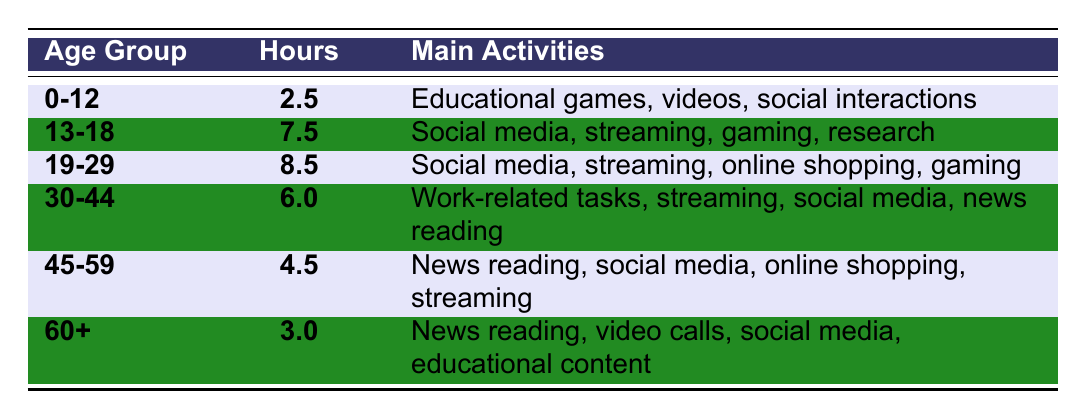What is the average daily internet usage for the age group 19-29? The value for the age group 19-29 is clearly listed in the table as 8.5 hours.
Answer: 8.5 hours Which age group has the highest average daily internet usage? By comparing the values in the table, 19-29 has the highest usage at 8.5 hours.
Answer: 19-29 How many hours do people aged 30-44 spend online daily? The table shows that the age group 30-44 spends 6.0 hours online.
Answer: 6.0 hours What activities do people aged 45-59 engage in online? The table lists the main activities for this age group as news reading, social media, online shopping, and streaming.
Answer: News reading, social media, online shopping, streaming Is the average daily internet usage for the age group 60+ higher than that of the age group 0-12? Comparing the two values, 3.0 hours (60+) is higher than 2.5 hours (0-12), which makes the statement true.
Answer: Yes What is the difference between the daily internet usage of 13-18 and 45-59 age groups? Subtracting the values gives us 7.5 hours (13-18) - 4.5 hours (45-59) = 3.0 hours difference.
Answer: 3.0 hours Which age group has an average usage of less than 5 hours? The age groups with usage less than 5 hours according to the table are 0-12 (2.5 hours) and 60+ (3.0 hours).
Answer: 0-12 and 60+ What activities are common among the oldest age group (60+)? The table outlines that for people aged 60 and above, common activities include news reading, video calls, social media, and educational content.
Answer: News reading, video calls, social media, educational content What is the sum of daily internet usage for age groups 0-12 and 30-44? Adding the values: 2.5 hours (0-12) + 6.0 hours (30-44) gives us 8.5 hours total.
Answer: 8.5 hours If you combine the daily internet usage for ages 19-29 and 45-59, what do you get? The total is calculated by summing 8.5 hours (19-29) and 4.5 hours (45-59), resulting in 13.0 hours.
Answer: 13.0 hours 